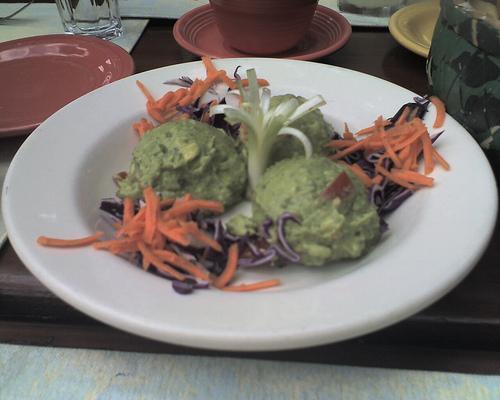What type of meal does this appear to be?
Answer the question by selecting the correct answer among the 4 following choices and explain your choice with a short sentence. The answer should be formatted with the following format: `Answer: choice
Rationale: rationale.`
Options: Meat lovers, vegetarian, chinese, italian. Answer: vegetarian.
Rationale: The meal is vegetarian. 